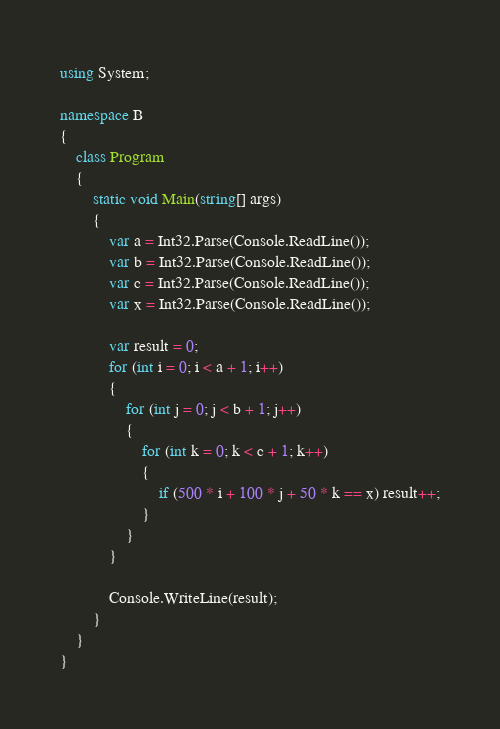Convert code to text. <code><loc_0><loc_0><loc_500><loc_500><_C#_>using System;

namespace B
{
    class Program
    {
        static void Main(string[] args)
        {
            var a = Int32.Parse(Console.ReadLine());
            var b = Int32.Parse(Console.ReadLine());
            var c = Int32.Parse(Console.ReadLine());
            var x = Int32.Parse(Console.ReadLine());

            var result = 0;
            for (int i = 0; i < a + 1; i++)
            {
                for (int j = 0; j < b + 1; j++)
                {
                    for (int k = 0; k < c + 1; k++)
                    {
                        if (500 * i + 100 * j + 50 * k == x) result++;
                    }
                }
            }

            Console.WriteLine(result);
        }
    }
}
</code> 